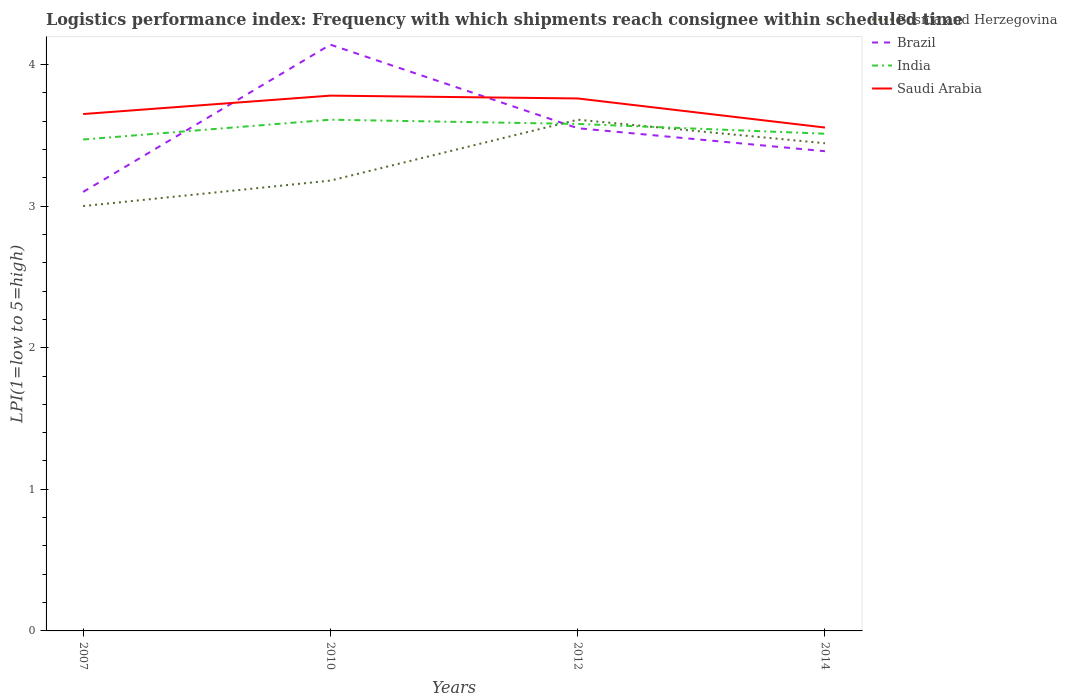How many different coloured lines are there?
Offer a very short reply. 4. Across all years, what is the maximum logistics performance index in Saudi Arabia?
Offer a terse response. 3.55. What is the total logistics performance index in India in the graph?
Your answer should be compact. 0.03. What is the difference between the highest and the second highest logistics performance index in Saudi Arabia?
Your answer should be compact. 0.23. Is the logistics performance index in Brazil strictly greater than the logistics performance index in Bosnia and Herzegovina over the years?
Ensure brevity in your answer.  No. How many years are there in the graph?
Provide a succinct answer. 4. What is the difference between two consecutive major ticks on the Y-axis?
Your answer should be compact. 1. Does the graph contain grids?
Your response must be concise. No. What is the title of the graph?
Your answer should be very brief. Logistics performance index: Frequency with which shipments reach consignee within scheduled time. Does "Russian Federation" appear as one of the legend labels in the graph?
Ensure brevity in your answer.  No. What is the label or title of the X-axis?
Offer a terse response. Years. What is the label or title of the Y-axis?
Offer a terse response. LPI(1=low to 5=high). What is the LPI(1=low to 5=high) of Bosnia and Herzegovina in 2007?
Keep it short and to the point. 3. What is the LPI(1=low to 5=high) in Brazil in 2007?
Provide a succinct answer. 3.1. What is the LPI(1=low to 5=high) in India in 2007?
Provide a short and direct response. 3.47. What is the LPI(1=low to 5=high) of Saudi Arabia in 2007?
Your response must be concise. 3.65. What is the LPI(1=low to 5=high) in Bosnia and Herzegovina in 2010?
Keep it short and to the point. 3.18. What is the LPI(1=low to 5=high) of Brazil in 2010?
Your response must be concise. 4.14. What is the LPI(1=low to 5=high) in India in 2010?
Offer a very short reply. 3.61. What is the LPI(1=low to 5=high) in Saudi Arabia in 2010?
Provide a succinct answer. 3.78. What is the LPI(1=low to 5=high) in Bosnia and Herzegovina in 2012?
Provide a short and direct response. 3.61. What is the LPI(1=low to 5=high) of Brazil in 2012?
Keep it short and to the point. 3.55. What is the LPI(1=low to 5=high) in India in 2012?
Your answer should be very brief. 3.58. What is the LPI(1=low to 5=high) in Saudi Arabia in 2012?
Offer a terse response. 3.76. What is the LPI(1=low to 5=high) in Bosnia and Herzegovina in 2014?
Provide a short and direct response. 3.44. What is the LPI(1=low to 5=high) in Brazil in 2014?
Make the answer very short. 3.39. What is the LPI(1=low to 5=high) in India in 2014?
Offer a terse response. 3.51. What is the LPI(1=low to 5=high) of Saudi Arabia in 2014?
Your answer should be compact. 3.55. Across all years, what is the maximum LPI(1=low to 5=high) of Bosnia and Herzegovina?
Your answer should be compact. 3.61. Across all years, what is the maximum LPI(1=low to 5=high) in Brazil?
Offer a very short reply. 4.14. Across all years, what is the maximum LPI(1=low to 5=high) in India?
Your answer should be compact. 3.61. Across all years, what is the maximum LPI(1=low to 5=high) in Saudi Arabia?
Make the answer very short. 3.78. Across all years, what is the minimum LPI(1=low to 5=high) of Brazil?
Your response must be concise. 3.1. Across all years, what is the minimum LPI(1=low to 5=high) in India?
Provide a succinct answer. 3.47. Across all years, what is the minimum LPI(1=low to 5=high) in Saudi Arabia?
Offer a very short reply. 3.55. What is the total LPI(1=low to 5=high) of Bosnia and Herzegovina in the graph?
Provide a short and direct response. 13.23. What is the total LPI(1=low to 5=high) in Brazil in the graph?
Ensure brevity in your answer.  14.18. What is the total LPI(1=low to 5=high) in India in the graph?
Give a very brief answer. 14.17. What is the total LPI(1=low to 5=high) in Saudi Arabia in the graph?
Your answer should be compact. 14.74. What is the difference between the LPI(1=low to 5=high) in Bosnia and Herzegovina in 2007 and that in 2010?
Your response must be concise. -0.18. What is the difference between the LPI(1=low to 5=high) of Brazil in 2007 and that in 2010?
Offer a terse response. -1.04. What is the difference between the LPI(1=low to 5=high) in India in 2007 and that in 2010?
Give a very brief answer. -0.14. What is the difference between the LPI(1=low to 5=high) in Saudi Arabia in 2007 and that in 2010?
Your answer should be very brief. -0.13. What is the difference between the LPI(1=low to 5=high) in Bosnia and Herzegovina in 2007 and that in 2012?
Your answer should be very brief. -0.61. What is the difference between the LPI(1=low to 5=high) of Brazil in 2007 and that in 2012?
Provide a succinct answer. -0.45. What is the difference between the LPI(1=low to 5=high) in India in 2007 and that in 2012?
Ensure brevity in your answer.  -0.11. What is the difference between the LPI(1=low to 5=high) of Saudi Arabia in 2007 and that in 2012?
Your answer should be compact. -0.11. What is the difference between the LPI(1=low to 5=high) of Bosnia and Herzegovina in 2007 and that in 2014?
Ensure brevity in your answer.  -0.44. What is the difference between the LPI(1=low to 5=high) in Brazil in 2007 and that in 2014?
Your answer should be very brief. -0.29. What is the difference between the LPI(1=low to 5=high) in India in 2007 and that in 2014?
Provide a short and direct response. -0.04. What is the difference between the LPI(1=low to 5=high) of Saudi Arabia in 2007 and that in 2014?
Your response must be concise. 0.1. What is the difference between the LPI(1=low to 5=high) of Bosnia and Herzegovina in 2010 and that in 2012?
Keep it short and to the point. -0.43. What is the difference between the LPI(1=low to 5=high) in Brazil in 2010 and that in 2012?
Give a very brief answer. 0.59. What is the difference between the LPI(1=low to 5=high) in India in 2010 and that in 2012?
Make the answer very short. 0.03. What is the difference between the LPI(1=low to 5=high) in Bosnia and Herzegovina in 2010 and that in 2014?
Provide a succinct answer. -0.26. What is the difference between the LPI(1=low to 5=high) of Brazil in 2010 and that in 2014?
Give a very brief answer. 0.75. What is the difference between the LPI(1=low to 5=high) in India in 2010 and that in 2014?
Your answer should be compact. 0.1. What is the difference between the LPI(1=low to 5=high) in Saudi Arabia in 2010 and that in 2014?
Provide a short and direct response. 0.23. What is the difference between the LPI(1=low to 5=high) of Bosnia and Herzegovina in 2012 and that in 2014?
Ensure brevity in your answer.  0.17. What is the difference between the LPI(1=low to 5=high) of Brazil in 2012 and that in 2014?
Offer a very short reply. 0.16. What is the difference between the LPI(1=low to 5=high) in India in 2012 and that in 2014?
Provide a short and direct response. 0.07. What is the difference between the LPI(1=low to 5=high) in Saudi Arabia in 2012 and that in 2014?
Keep it short and to the point. 0.21. What is the difference between the LPI(1=low to 5=high) in Bosnia and Herzegovina in 2007 and the LPI(1=low to 5=high) in Brazil in 2010?
Give a very brief answer. -1.14. What is the difference between the LPI(1=low to 5=high) of Bosnia and Herzegovina in 2007 and the LPI(1=low to 5=high) of India in 2010?
Ensure brevity in your answer.  -0.61. What is the difference between the LPI(1=low to 5=high) of Bosnia and Herzegovina in 2007 and the LPI(1=low to 5=high) of Saudi Arabia in 2010?
Give a very brief answer. -0.78. What is the difference between the LPI(1=low to 5=high) in Brazil in 2007 and the LPI(1=low to 5=high) in India in 2010?
Your answer should be compact. -0.51. What is the difference between the LPI(1=low to 5=high) in Brazil in 2007 and the LPI(1=low to 5=high) in Saudi Arabia in 2010?
Your response must be concise. -0.68. What is the difference between the LPI(1=low to 5=high) of India in 2007 and the LPI(1=low to 5=high) of Saudi Arabia in 2010?
Offer a terse response. -0.31. What is the difference between the LPI(1=low to 5=high) in Bosnia and Herzegovina in 2007 and the LPI(1=low to 5=high) in Brazil in 2012?
Keep it short and to the point. -0.55. What is the difference between the LPI(1=low to 5=high) of Bosnia and Herzegovina in 2007 and the LPI(1=low to 5=high) of India in 2012?
Ensure brevity in your answer.  -0.58. What is the difference between the LPI(1=low to 5=high) in Bosnia and Herzegovina in 2007 and the LPI(1=low to 5=high) in Saudi Arabia in 2012?
Give a very brief answer. -0.76. What is the difference between the LPI(1=low to 5=high) in Brazil in 2007 and the LPI(1=low to 5=high) in India in 2012?
Keep it short and to the point. -0.48. What is the difference between the LPI(1=low to 5=high) in Brazil in 2007 and the LPI(1=low to 5=high) in Saudi Arabia in 2012?
Your answer should be very brief. -0.66. What is the difference between the LPI(1=low to 5=high) in India in 2007 and the LPI(1=low to 5=high) in Saudi Arabia in 2012?
Your response must be concise. -0.29. What is the difference between the LPI(1=low to 5=high) in Bosnia and Herzegovina in 2007 and the LPI(1=low to 5=high) in Brazil in 2014?
Provide a short and direct response. -0.39. What is the difference between the LPI(1=low to 5=high) in Bosnia and Herzegovina in 2007 and the LPI(1=low to 5=high) in India in 2014?
Make the answer very short. -0.51. What is the difference between the LPI(1=low to 5=high) of Bosnia and Herzegovina in 2007 and the LPI(1=low to 5=high) of Saudi Arabia in 2014?
Give a very brief answer. -0.55. What is the difference between the LPI(1=low to 5=high) in Brazil in 2007 and the LPI(1=low to 5=high) in India in 2014?
Keep it short and to the point. -0.41. What is the difference between the LPI(1=low to 5=high) of Brazil in 2007 and the LPI(1=low to 5=high) of Saudi Arabia in 2014?
Make the answer very short. -0.45. What is the difference between the LPI(1=low to 5=high) of India in 2007 and the LPI(1=low to 5=high) of Saudi Arabia in 2014?
Provide a short and direct response. -0.08. What is the difference between the LPI(1=low to 5=high) of Bosnia and Herzegovina in 2010 and the LPI(1=low to 5=high) of Brazil in 2012?
Keep it short and to the point. -0.37. What is the difference between the LPI(1=low to 5=high) of Bosnia and Herzegovina in 2010 and the LPI(1=low to 5=high) of India in 2012?
Keep it short and to the point. -0.4. What is the difference between the LPI(1=low to 5=high) of Bosnia and Herzegovina in 2010 and the LPI(1=low to 5=high) of Saudi Arabia in 2012?
Provide a short and direct response. -0.58. What is the difference between the LPI(1=low to 5=high) in Brazil in 2010 and the LPI(1=low to 5=high) in India in 2012?
Provide a succinct answer. 0.56. What is the difference between the LPI(1=low to 5=high) of Brazil in 2010 and the LPI(1=low to 5=high) of Saudi Arabia in 2012?
Give a very brief answer. 0.38. What is the difference between the LPI(1=low to 5=high) in Bosnia and Herzegovina in 2010 and the LPI(1=low to 5=high) in Brazil in 2014?
Your answer should be compact. -0.21. What is the difference between the LPI(1=low to 5=high) of Bosnia and Herzegovina in 2010 and the LPI(1=low to 5=high) of India in 2014?
Offer a terse response. -0.33. What is the difference between the LPI(1=low to 5=high) in Bosnia and Herzegovina in 2010 and the LPI(1=low to 5=high) in Saudi Arabia in 2014?
Your answer should be compact. -0.37. What is the difference between the LPI(1=low to 5=high) of Brazil in 2010 and the LPI(1=low to 5=high) of India in 2014?
Offer a terse response. 0.63. What is the difference between the LPI(1=low to 5=high) of Brazil in 2010 and the LPI(1=low to 5=high) of Saudi Arabia in 2014?
Your response must be concise. 0.59. What is the difference between the LPI(1=low to 5=high) of India in 2010 and the LPI(1=low to 5=high) of Saudi Arabia in 2014?
Your answer should be compact. 0.06. What is the difference between the LPI(1=low to 5=high) of Bosnia and Herzegovina in 2012 and the LPI(1=low to 5=high) of Brazil in 2014?
Your answer should be compact. 0.22. What is the difference between the LPI(1=low to 5=high) of Bosnia and Herzegovina in 2012 and the LPI(1=low to 5=high) of India in 2014?
Your answer should be compact. 0.1. What is the difference between the LPI(1=low to 5=high) of Bosnia and Herzegovina in 2012 and the LPI(1=low to 5=high) of Saudi Arabia in 2014?
Provide a short and direct response. 0.06. What is the difference between the LPI(1=low to 5=high) of Brazil in 2012 and the LPI(1=low to 5=high) of India in 2014?
Your answer should be very brief. 0.04. What is the difference between the LPI(1=low to 5=high) in Brazil in 2012 and the LPI(1=low to 5=high) in Saudi Arabia in 2014?
Ensure brevity in your answer.  -0. What is the difference between the LPI(1=low to 5=high) in India in 2012 and the LPI(1=low to 5=high) in Saudi Arabia in 2014?
Make the answer very short. 0.03. What is the average LPI(1=low to 5=high) of Bosnia and Herzegovina per year?
Offer a terse response. 3.31. What is the average LPI(1=low to 5=high) in Brazil per year?
Offer a very short reply. 3.54. What is the average LPI(1=low to 5=high) of India per year?
Make the answer very short. 3.54. What is the average LPI(1=low to 5=high) of Saudi Arabia per year?
Ensure brevity in your answer.  3.69. In the year 2007, what is the difference between the LPI(1=low to 5=high) of Bosnia and Herzegovina and LPI(1=low to 5=high) of Brazil?
Ensure brevity in your answer.  -0.1. In the year 2007, what is the difference between the LPI(1=low to 5=high) in Bosnia and Herzegovina and LPI(1=low to 5=high) in India?
Make the answer very short. -0.47. In the year 2007, what is the difference between the LPI(1=low to 5=high) in Bosnia and Herzegovina and LPI(1=low to 5=high) in Saudi Arabia?
Provide a short and direct response. -0.65. In the year 2007, what is the difference between the LPI(1=low to 5=high) of Brazil and LPI(1=low to 5=high) of India?
Keep it short and to the point. -0.37. In the year 2007, what is the difference between the LPI(1=low to 5=high) in Brazil and LPI(1=low to 5=high) in Saudi Arabia?
Your response must be concise. -0.55. In the year 2007, what is the difference between the LPI(1=low to 5=high) in India and LPI(1=low to 5=high) in Saudi Arabia?
Offer a terse response. -0.18. In the year 2010, what is the difference between the LPI(1=low to 5=high) of Bosnia and Herzegovina and LPI(1=low to 5=high) of Brazil?
Keep it short and to the point. -0.96. In the year 2010, what is the difference between the LPI(1=low to 5=high) in Bosnia and Herzegovina and LPI(1=low to 5=high) in India?
Your response must be concise. -0.43. In the year 2010, what is the difference between the LPI(1=low to 5=high) in Bosnia and Herzegovina and LPI(1=low to 5=high) in Saudi Arabia?
Give a very brief answer. -0.6. In the year 2010, what is the difference between the LPI(1=low to 5=high) in Brazil and LPI(1=low to 5=high) in India?
Your answer should be compact. 0.53. In the year 2010, what is the difference between the LPI(1=low to 5=high) in Brazil and LPI(1=low to 5=high) in Saudi Arabia?
Make the answer very short. 0.36. In the year 2010, what is the difference between the LPI(1=low to 5=high) of India and LPI(1=low to 5=high) of Saudi Arabia?
Keep it short and to the point. -0.17. In the year 2012, what is the difference between the LPI(1=low to 5=high) of Bosnia and Herzegovina and LPI(1=low to 5=high) of India?
Keep it short and to the point. 0.03. In the year 2012, what is the difference between the LPI(1=low to 5=high) of Brazil and LPI(1=low to 5=high) of India?
Your answer should be very brief. -0.03. In the year 2012, what is the difference between the LPI(1=low to 5=high) of Brazil and LPI(1=low to 5=high) of Saudi Arabia?
Make the answer very short. -0.21. In the year 2012, what is the difference between the LPI(1=low to 5=high) in India and LPI(1=low to 5=high) in Saudi Arabia?
Offer a terse response. -0.18. In the year 2014, what is the difference between the LPI(1=low to 5=high) of Bosnia and Herzegovina and LPI(1=low to 5=high) of Brazil?
Ensure brevity in your answer.  0.06. In the year 2014, what is the difference between the LPI(1=low to 5=high) of Bosnia and Herzegovina and LPI(1=low to 5=high) of India?
Your answer should be compact. -0.07. In the year 2014, what is the difference between the LPI(1=low to 5=high) in Bosnia and Herzegovina and LPI(1=low to 5=high) in Saudi Arabia?
Keep it short and to the point. -0.11. In the year 2014, what is the difference between the LPI(1=low to 5=high) of Brazil and LPI(1=low to 5=high) of India?
Keep it short and to the point. -0.12. In the year 2014, what is the difference between the LPI(1=low to 5=high) of Brazil and LPI(1=low to 5=high) of Saudi Arabia?
Your answer should be very brief. -0.17. In the year 2014, what is the difference between the LPI(1=low to 5=high) of India and LPI(1=low to 5=high) of Saudi Arabia?
Your response must be concise. -0.04. What is the ratio of the LPI(1=low to 5=high) of Bosnia and Herzegovina in 2007 to that in 2010?
Your answer should be very brief. 0.94. What is the ratio of the LPI(1=low to 5=high) of Brazil in 2007 to that in 2010?
Offer a terse response. 0.75. What is the ratio of the LPI(1=low to 5=high) in India in 2007 to that in 2010?
Give a very brief answer. 0.96. What is the ratio of the LPI(1=low to 5=high) in Saudi Arabia in 2007 to that in 2010?
Your answer should be very brief. 0.97. What is the ratio of the LPI(1=low to 5=high) in Bosnia and Herzegovina in 2007 to that in 2012?
Offer a very short reply. 0.83. What is the ratio of the LPI(1=low to 5=high) of Brazil in 2007 to that in 2012?
Provide a succinct answer. 0.87. What is the ratio of the LPI(1=low to 5=high) of India in 2007 to that in 2012?
Offer a terse response. 0.97. What is the ratio of the LPI(1=low to 5=high) of Saudi Arabia in 2007 to that in 2012?
Give a very brief answer. 0.97. What is the ratio of the LPI(1=low to 5=high) of Bosnia and Herzegovina in 2007 to that in 2014?
Provide a succinct answer. 0.87. What is the ratio of the LPI(1=low to 5=high) in Brazil in 2007 to that in 2014?
Offer a terse response. 0.92. What is the ratio of the LPI(1=low to 5=high) in India in 2007 to that in 2014?
Make the answer very short. 0.99. What is the ratio of the LPI(1=low to 5=high) of Saudi Arabia in 2007 to that in 2014?
Keep it short and to the point. 1.03. What is the ratio of the LPI(1=low to 5=high) in Bosnia and Herzegovina in 2010 to that in 2012?
Make the answer very short. 0.88. What is the ratio of the LPI(1=low to 5=high) in Brazil in 2010 to that in 2012?
Offer a terse response. 1.17. What is the ratio of the LPI(1=low to 5=high) of India in 2010 to that in 2012?
Your response must be concise. 1.01. What is the ratio of the LPI(1=low to 5=high) of Saudi Arabia in 2010 to that in 2012?
Your response must be concise. 1.01. What is the ratio of the LPI(1=low to 5=high) in Bosnia and Herzegovina in 2010 to that in 2014?
Make the answer very short. 0.92. What is the ratio of the LPI(1=low to 5=high) of Brazil in 2010 to that in 2014?
Provide a succinct answer. 1.22. What is the ratio of the LPI(1=low to 5=high) of India in 2010 to that in 2014?
Offer a terse response. 1.03. What is the ratio of the LPI(1=low to 5=high) in Saudi Arabia in 2010 to that in 2014?
Offer a very short reply. 1.06. What is the ratio of the LPI(1=low to 5=high) of Bosnia and Herzegovina in 2012 to that in 2014?
Offer a terse response. 1.05. What is the ratio of the LPI(1=low to 5=high) in Brazil in 2012 to that in 2014?
Provide a succinct answer. 1.05. What is the ratio of the LPI(1=low to 5=high) in India in 2012 to that in 2014?
Give a very brief answer. 1.02. What is the ratio of the LPI(1=low to 5=high) in Saudi Arabia in 2012 to that in 2014?
Offer a very short reply. 1.06. What is the difference between the highest and the second highest LPI(1=low to 5=high) in Bosnia and Herzegovina?
Give a very brief answer. 0.17. What is the difference between the highest and the second highest LPI(1=low to 5=high) in Brazil?
Offer a very short reply. 0.59. What is the difference between the highest and the second highest LPI(1=low to 5=high) in India?
Make the answer very short. 0.03. What is the difference between the highest and the lowest LPI(1=low to 5=high) of Bosnia and Herzegovina?
Keep it short and to the point. 0.61. What is the difference between the highest and the lowest LPI(1=low to 5=high) in Brazil?
Your answer should be very brief. 1.04. What is the difference between the highest and the lowest LPI(1=low to 5=high) of India?
Your response must be concise. 0.14. What is the difference between the highest and the lowest LPI(1=low to 5=high) of Saudi Arabia?
Provide a short and direct response. 0.23. 